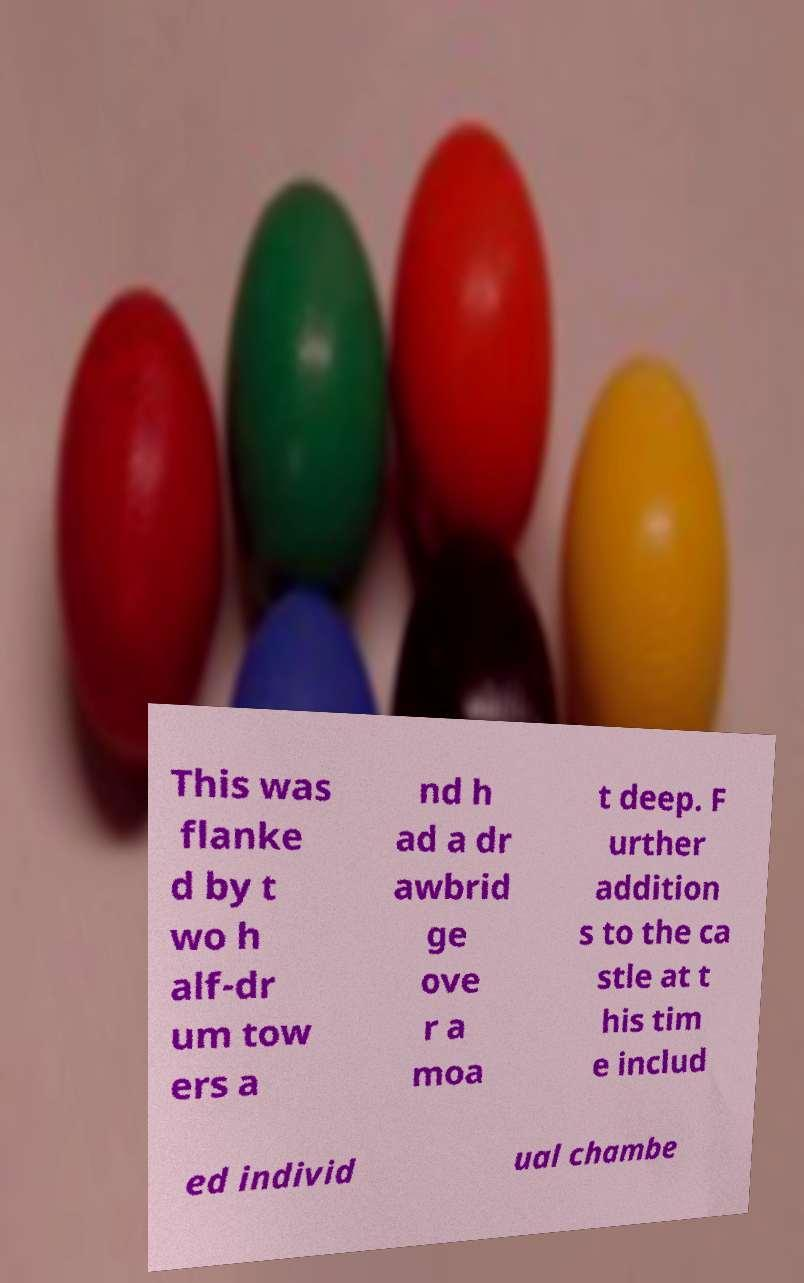Can you accurately transcribe the text from the provided image for me? This was flanke d by t wo h alf-dr um tow ers a nd h ad a dr awbrid ge ove r a moa t deep. F urther addition s to the ca stle at t his tim e includ ed individ ual chambe 